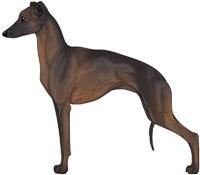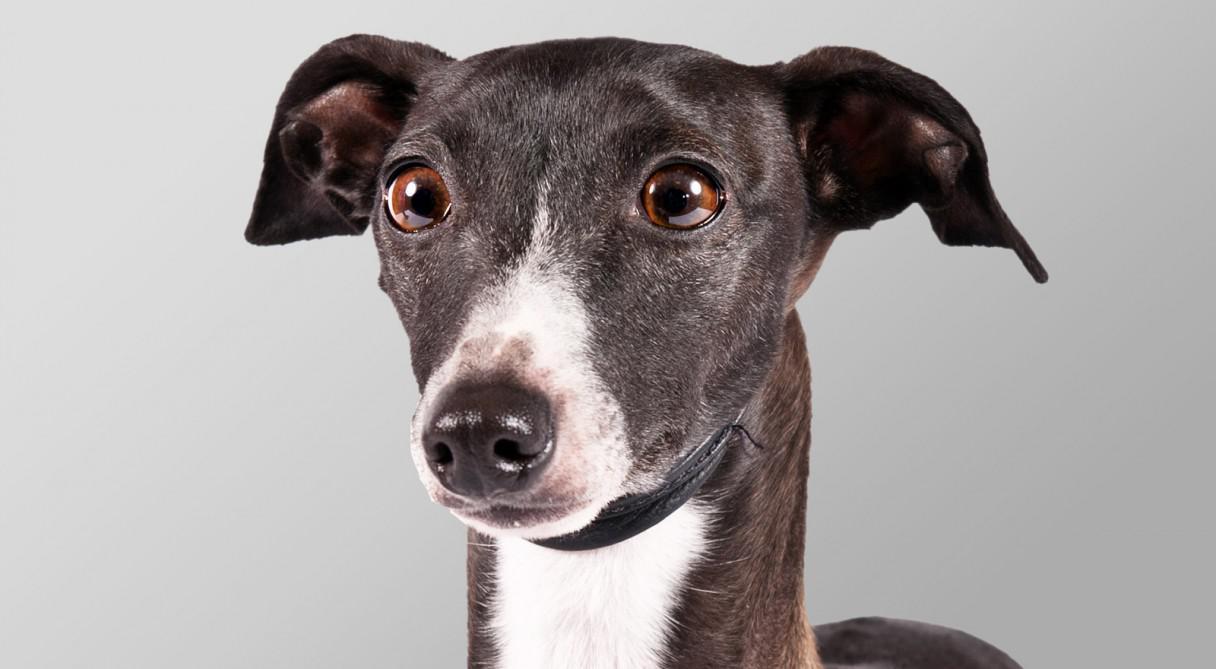The first image is the image on the left, the second image is the image on the right. Considering the images on both sides, is "In total, more than one dog is wearing something around its neck." valid? Answer yes or no. No. 